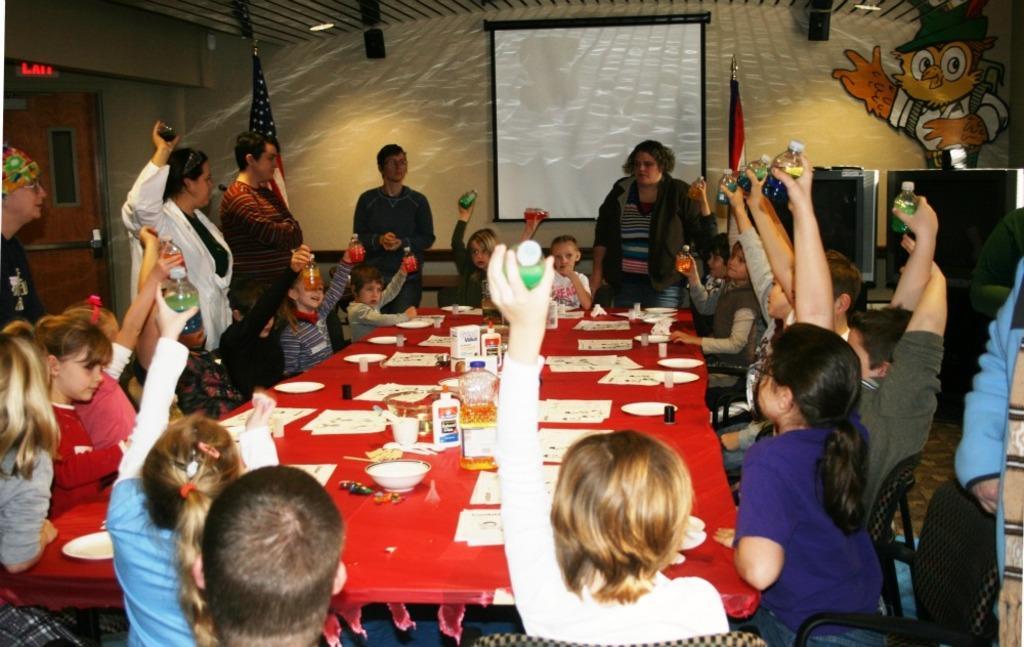In one or two sentences, can you explain what this image depicts? Here there are few kids sitting on the chair at the table and holding colorful bottles in their hands and also with them there are few men and women around them. On the table we can see papers,plates,glasses. In the background there is a wall,posters,screen,TV and a flag. 